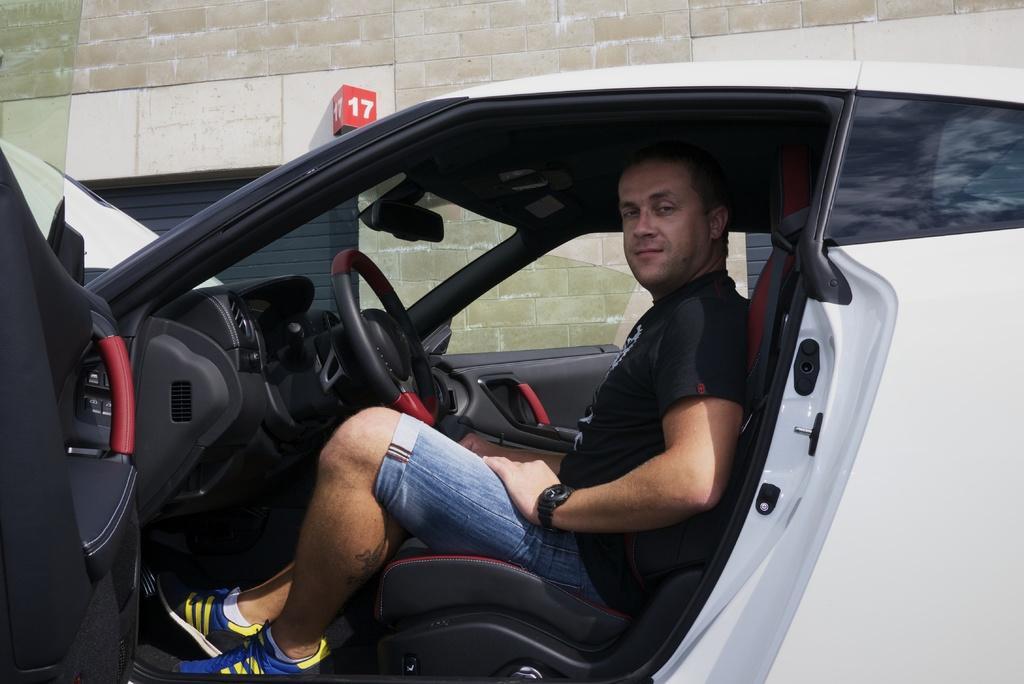Describe this image in one or two sentences. In the image there is a white car. Inside the car there is a man with black t-shirt and blue short is sitting on the seat. In front of him there is a steering. At the top of the image there is a wall with red color block with seventeen number on it. 